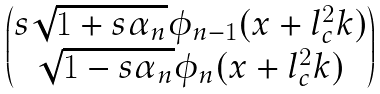<formula> <loc_0><loc_0><loc_500><loc_500>\begin{pmatrix} s \sqrt { 1 + s \alpha _ { n } } \phi _ { n - 1 } ( x + l _ { c } ^ { 2 } k ) \\ \sqrt { 1 - s \alpha _ { n } } \phi _ { n } ( x + l _ { c } ^ { 2 } k ) \end{pmatrix}</formula> 